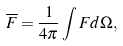<formula> <loc_0><loc_0><loc_500><loc_500>\overline { F } = \frac { 1 } { 4 \pi } \int F d \Omega ,</formula> 